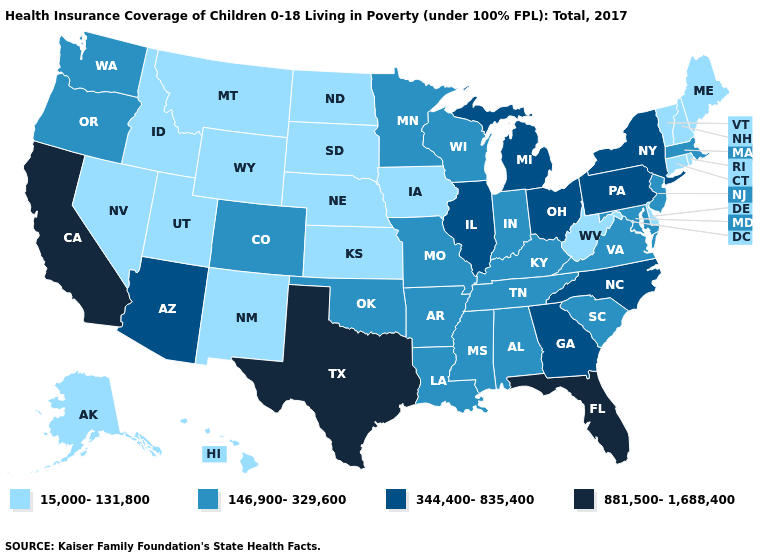Does Texas have the highest value in the South?
Give a very brief answer. Yes. Name the states that have a value in the range 146,900-329,600?
Answer briefly. Alabama, Arkansas, Colorado, Indiana, Kentucky, Louisiana, Maryland, Massachusetts, Minnesota, Mississippi, Missouri, New Jersey, Oklahoma, Oregon, South Carolina, Tennessee, Virginia, Washington, Wisconsin. What is the lowest value in the South?
Write a very short answer. 15,000-131,800. Does Kansas have the lowest value in the MidWest?
Keep it brief. Yes. What is the value of Mississippi?
Keep it brief. 146,900-329,600. Is the legend a continuous bar?
Write a very short answer. No. Name the states that have a value in the range 15,000-131,800?
Quick response, please. Alaska, Connecticut, Delaware, Hawaii, Idaho, Iowa, Kansas, Maine, Montana, Nebraska, Nevada, New Hampshire, New Mexico, North Dakota, Rhode Island, South Dakota, Utah, Vermont, West Virginia, Wyoming. What is the value of Louisiana?
Give a very brief answer. 146,900-329,600. Name the states that have a value in the range 344,400-835,400?
Be succinct. Arizona, Georgia, Illinois, Michigan, New York, North Carolina, Ohio, Pennsylvania. What is the highest value in the USA?
Be succinct. 881,500-1,688,400. How many symbols are there in the legend?
Concise answer only. 4. Name the states that have a value in the range 146,900-329,600?
Answer briefly. Alabama, Arkansas, Colorado, Indiana, Kentucky, Louisiana, Maryland, Massachusetts, Minnesota, Mississippi, Missouri, New Jersey, Oklahoma, Oregon, South Carolina, Tennessee, Virginia, Washington, Wisconsin. What is the lowest value in states that border Louisiana?
Be succinct. 146,900-329,600. Does South Carolina have the lowest value in the USA?
Keep it brief. No. Among the states that border New Jersey , which have the lowest value?
Concise answer only. Delaware. 